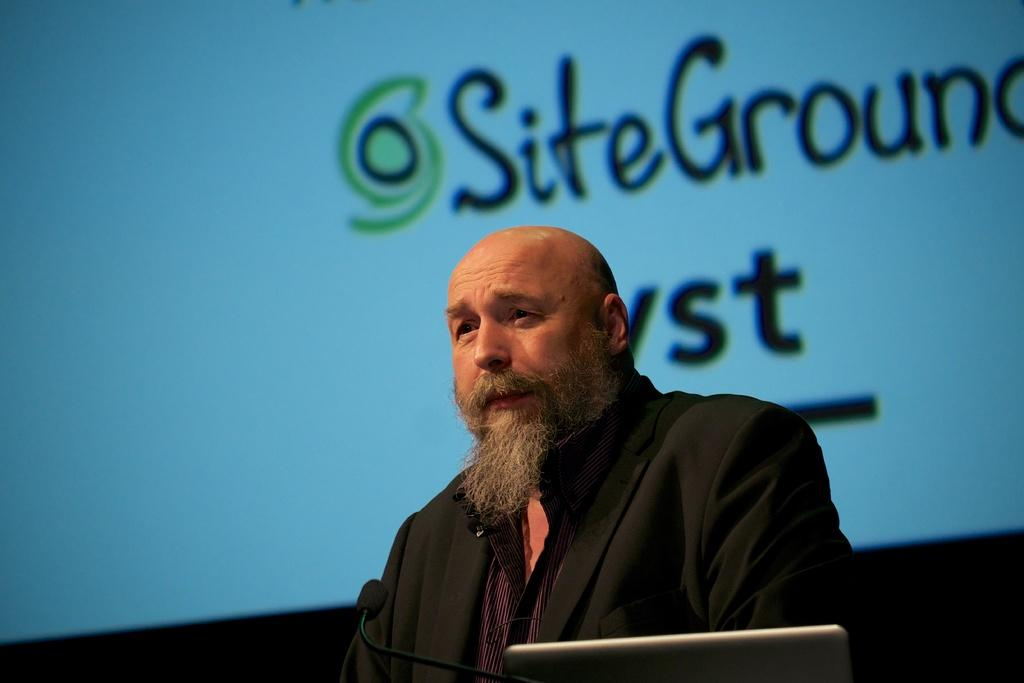Who is present in the image? There is a man in the image. What is the man wearing? The man is wearing a black suit. What object can be seen in the image that is typically used for amplifying sound? There is a microphone in the image. What electronic device is visible in the image? There is a laptop in the image. What can be seen on the screen in the background? There is text visible on a screen in the background. What type of cars are parked outside the hospital in the image? There is no mention of cars or a hospital in the image; it features a man, a black suit, a microphone, a laptop, and text on a screen in the background. 